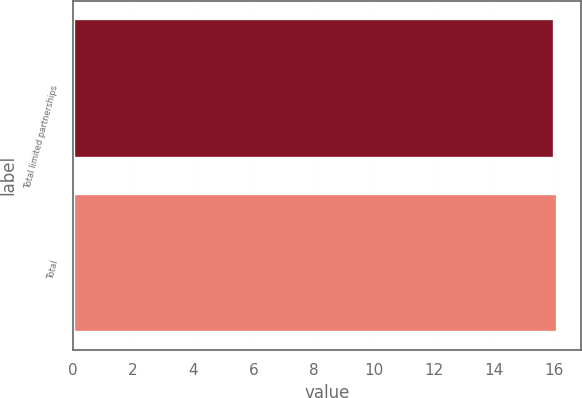<chart> <loc_0><loc_0><loc_500><loc_500><bar_chart><fcel>Total limited partnerships<fcel>Total<nl><fcel>16<fcel>16.1<nl></chart> 